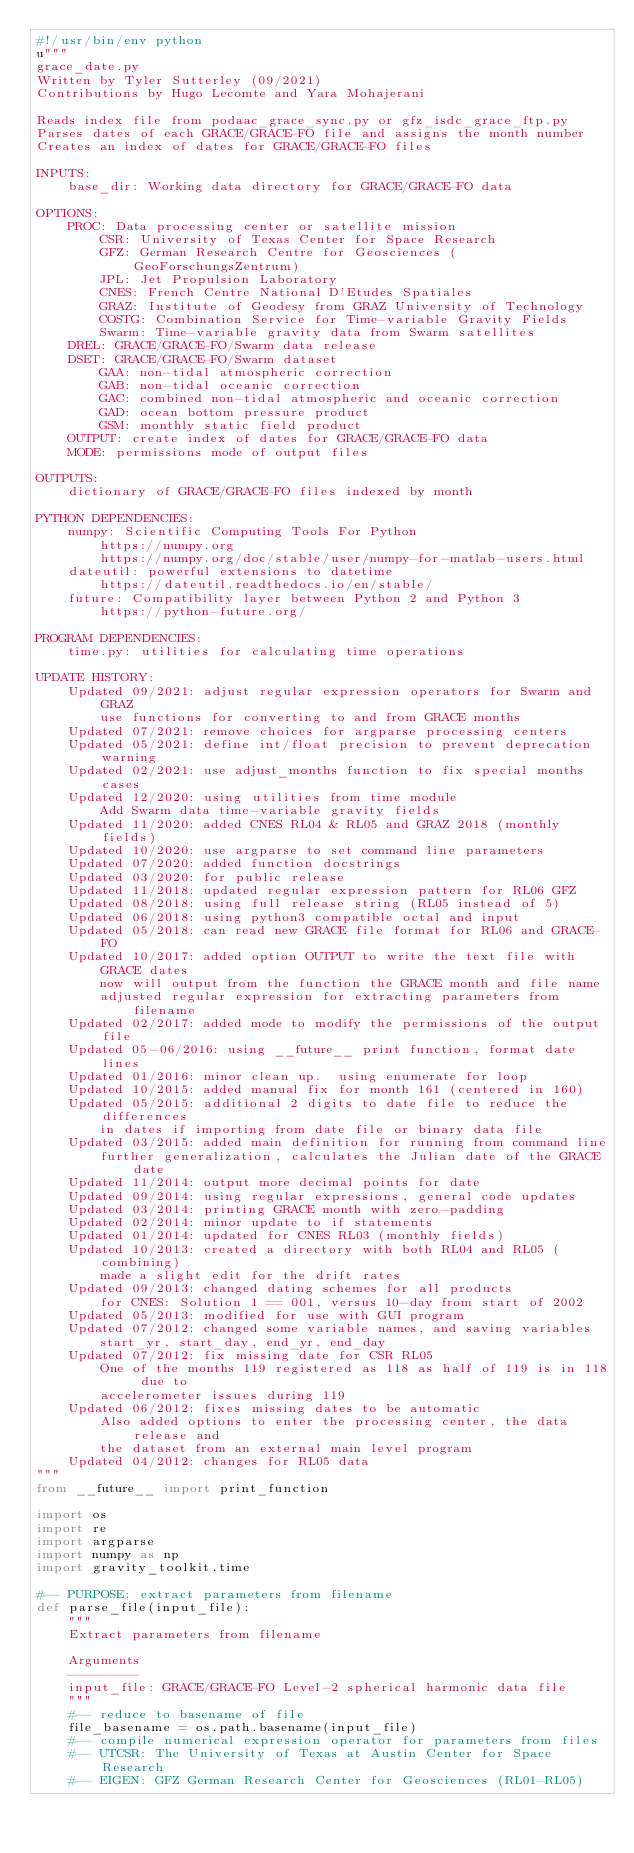<code> <loc_0><loc_0><loc_500><loc_500><_Python_>#!/usr/bin/env python
u"""
grace_date.py
Written by Tyler Sutterley (09/2021)
Contributions by Hugo Lecomte and Yara Mohajerani

Reads index file from podaac_grace_sync.py or gfz_isdc_grace_ftp.py
Parses dates of each GRACE/GRACE-FO file and assigns the month number
Creates an index of dates for GRACE/GRACE-FO files

INPUTS:
    base_dir: Working data directory for GRACE/GRACE-FO data

OPTIONS:
    PROC: Data processing center or satellite mission
        CSR: University of Texas Center for Space Research
        GFZ: German Research Centre for Geosciences (GeoForschungsZentrum)
        JPL: Jet Propulsion Laboratory
        CNES: French Centre National D'Etudes Spatiales
        GRAZ: Institute of Geodesy from GRAZ University of Technology
        COSTG: Combination Service for Time-variable Gravity Fields
        Swarm: Time-variable gravity data from Swarm satellites
    DREL: GRACE/GRACE-FO/Swarm data release
    DSET: GRACE/GRACE-FO/Swarm dataset
        GAA: non-tidal atmospheric correction
        GAB: non-tidal oceanic correction
        GAC: combined non-tidal atmospheric and oceanic correction
        GAD: ocean bottom pressure product
        GSM: monthly static field product
    OUTPUT: create index of dates for GRACE/GRACE-FO data
    MODE: permissions mode of output files

OUTPUTS:
    dictionary of GRACE/GRACE-FO files indexed by month

PYTHON DEPENDENCIES:
    numpy: Scientific Computing Tools For Python
        https://numpy.org
        https://numpy.org/doc/stable/user/numpy-for-matlab-users.html
    dateutil: powerful extensions to datetime
        https://dateutil.readthedocs.io/en/stable/
    future: Compatibility layer between Python 2 and Python 3
        https://python-future.org/

PROGRAM DEPENDENCIES:
    time.py: utilities for calculating time operations

UPDATE HISTORY:
    Updated 09/2021: adjust regular expression operators for Swarm and GRAZ
        use functions for converting to and from GRACE months
    Updated 07/2021: remove choices for argparse processing centers
    Updated 05/2021: define int/float precision to prevent deprecation warning
    Updated 02/2021: use adjust_months function to fix special months cases
    Updated 12/2020: using utilities from time module
        Add Swarm data time-variable gravity fields
    Updated 11/2020: added CNES RL04 & RL05 and GRAZ 2018 (monthly fields)
    Updated 10/2020: use argparse to set command line parameters
    Updated 07/2020: added function docstrings
    Updated 03/2020: for public release
    Updated 11/2018: updated regular expression pattern for RL06 GFZ
    Updated 08/2018: using full release string (RL05 instead of 5)
    Updated 06/2018: using python3 compatible octal and input
    Updated 05/2018: can read new GRACE file format for RL06 and GRACE-FO
    Updated 10/2017: added option OUTPUT to write the text file with GRACE dates
        now will output from the function the GRACE month and file name
        adjusted regular expression for extracting parameters from filename
    Updated 02/2017: added mode to modify the permissions of the output file
    Updated 05-06/2016: using __future__ print function, format date lines
    Updated 01/2016: minor clean up.  using enumerate for loop
    Updated 10/2015: added manual fix for month 161 (centered in 160)
    Updated 05/2015: additional 2 digits to date file to reduce the differences
        in dates if importing from date file or binary data file
    Updated 03/2015: added main definition for running from command line
        further generalization, calculates the Julian date of the GRACE date
    Updated 11/2014: output more decimal points for date
    Updated 09/2014: using regular expressions, general code updates
    Updated 03/2014: printing GRACE month with zero-padding
    Updated 02/2014: minor update to if statements
    Updated 01/2014: updated for CNES RL03 (monthly fields)
    Updated 10/2013: created a directory with both RL04 and RL05 (combining)
        made a slight edit for the drift rates
    Updated 09/2013: changed dating schemes for all products
        for CNES: Solution 1 == 001, versus 10-day from start of 2002
    Updated 05/2013: modified for use with GUI program
    Updated 07/2012: changed some variable names, and saving variables
        start_yr, start_day, end_yr, end_day
    Updated 07/2012: fix missing date for CSR RL05
        One of the months 119 registered as 118 as half of 119 is in 118 due to
        accelerometer issues during 119
    Updated 06/2012: fixes missing dates to be automatic
        Also added options to enter the processing center, the data release and
        the dataset from an external main level program
    Updated 04/2012: changes for RL05 data
"""
from __future__ import print_function

import os
import re
import argparse
import numpy as np
import gravity_toolkit.time

#-- PURPOSE: extract parameters from filename
def parse_file(input_file):
    """
    Extract parameters from filename

    Arguments
    ---------
    input_file: GRACE/GRACE-FO Level-2 spherical harmonic data file
    """
    #-- reduce to basename of file
    file_basename = os.path.basename(input_file)
    #-- compile numerical expression operator for parameters from files
    #-- UTCSR: The University of Texas at Austin Center for Space Research
    #-- EIGEN: GFZ German Research Center for Geosciences (RL01-RL05)</code> 